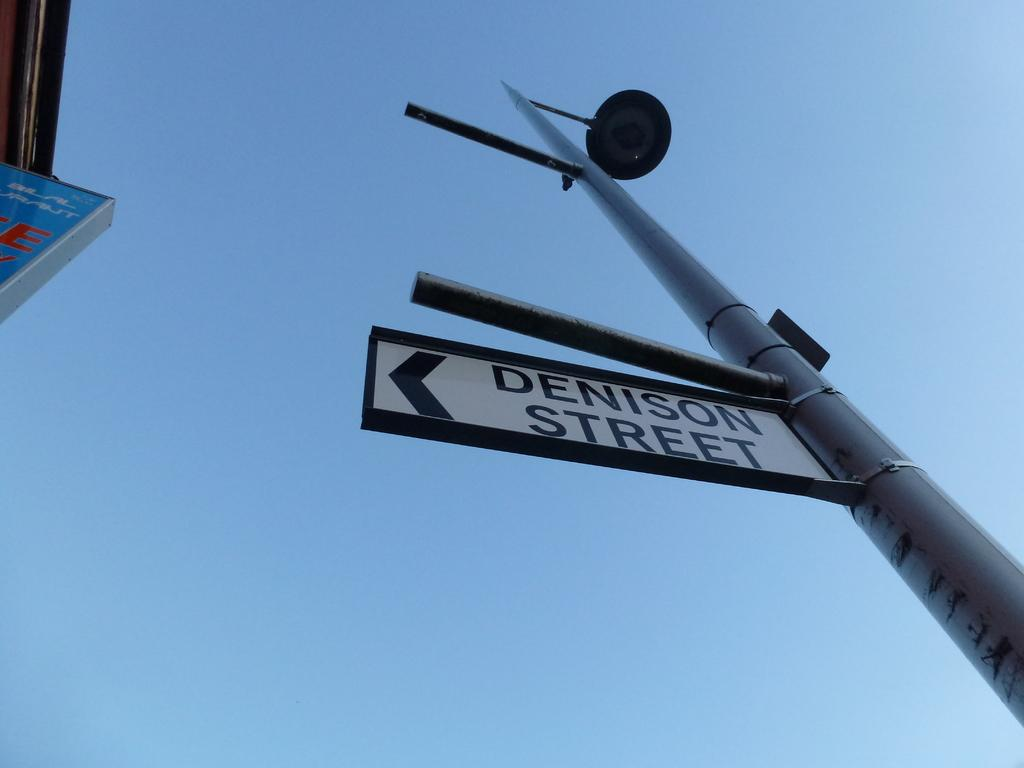<image>
Share a concise interpretation of the image provided. Street sign that shows Denison Street in black, 